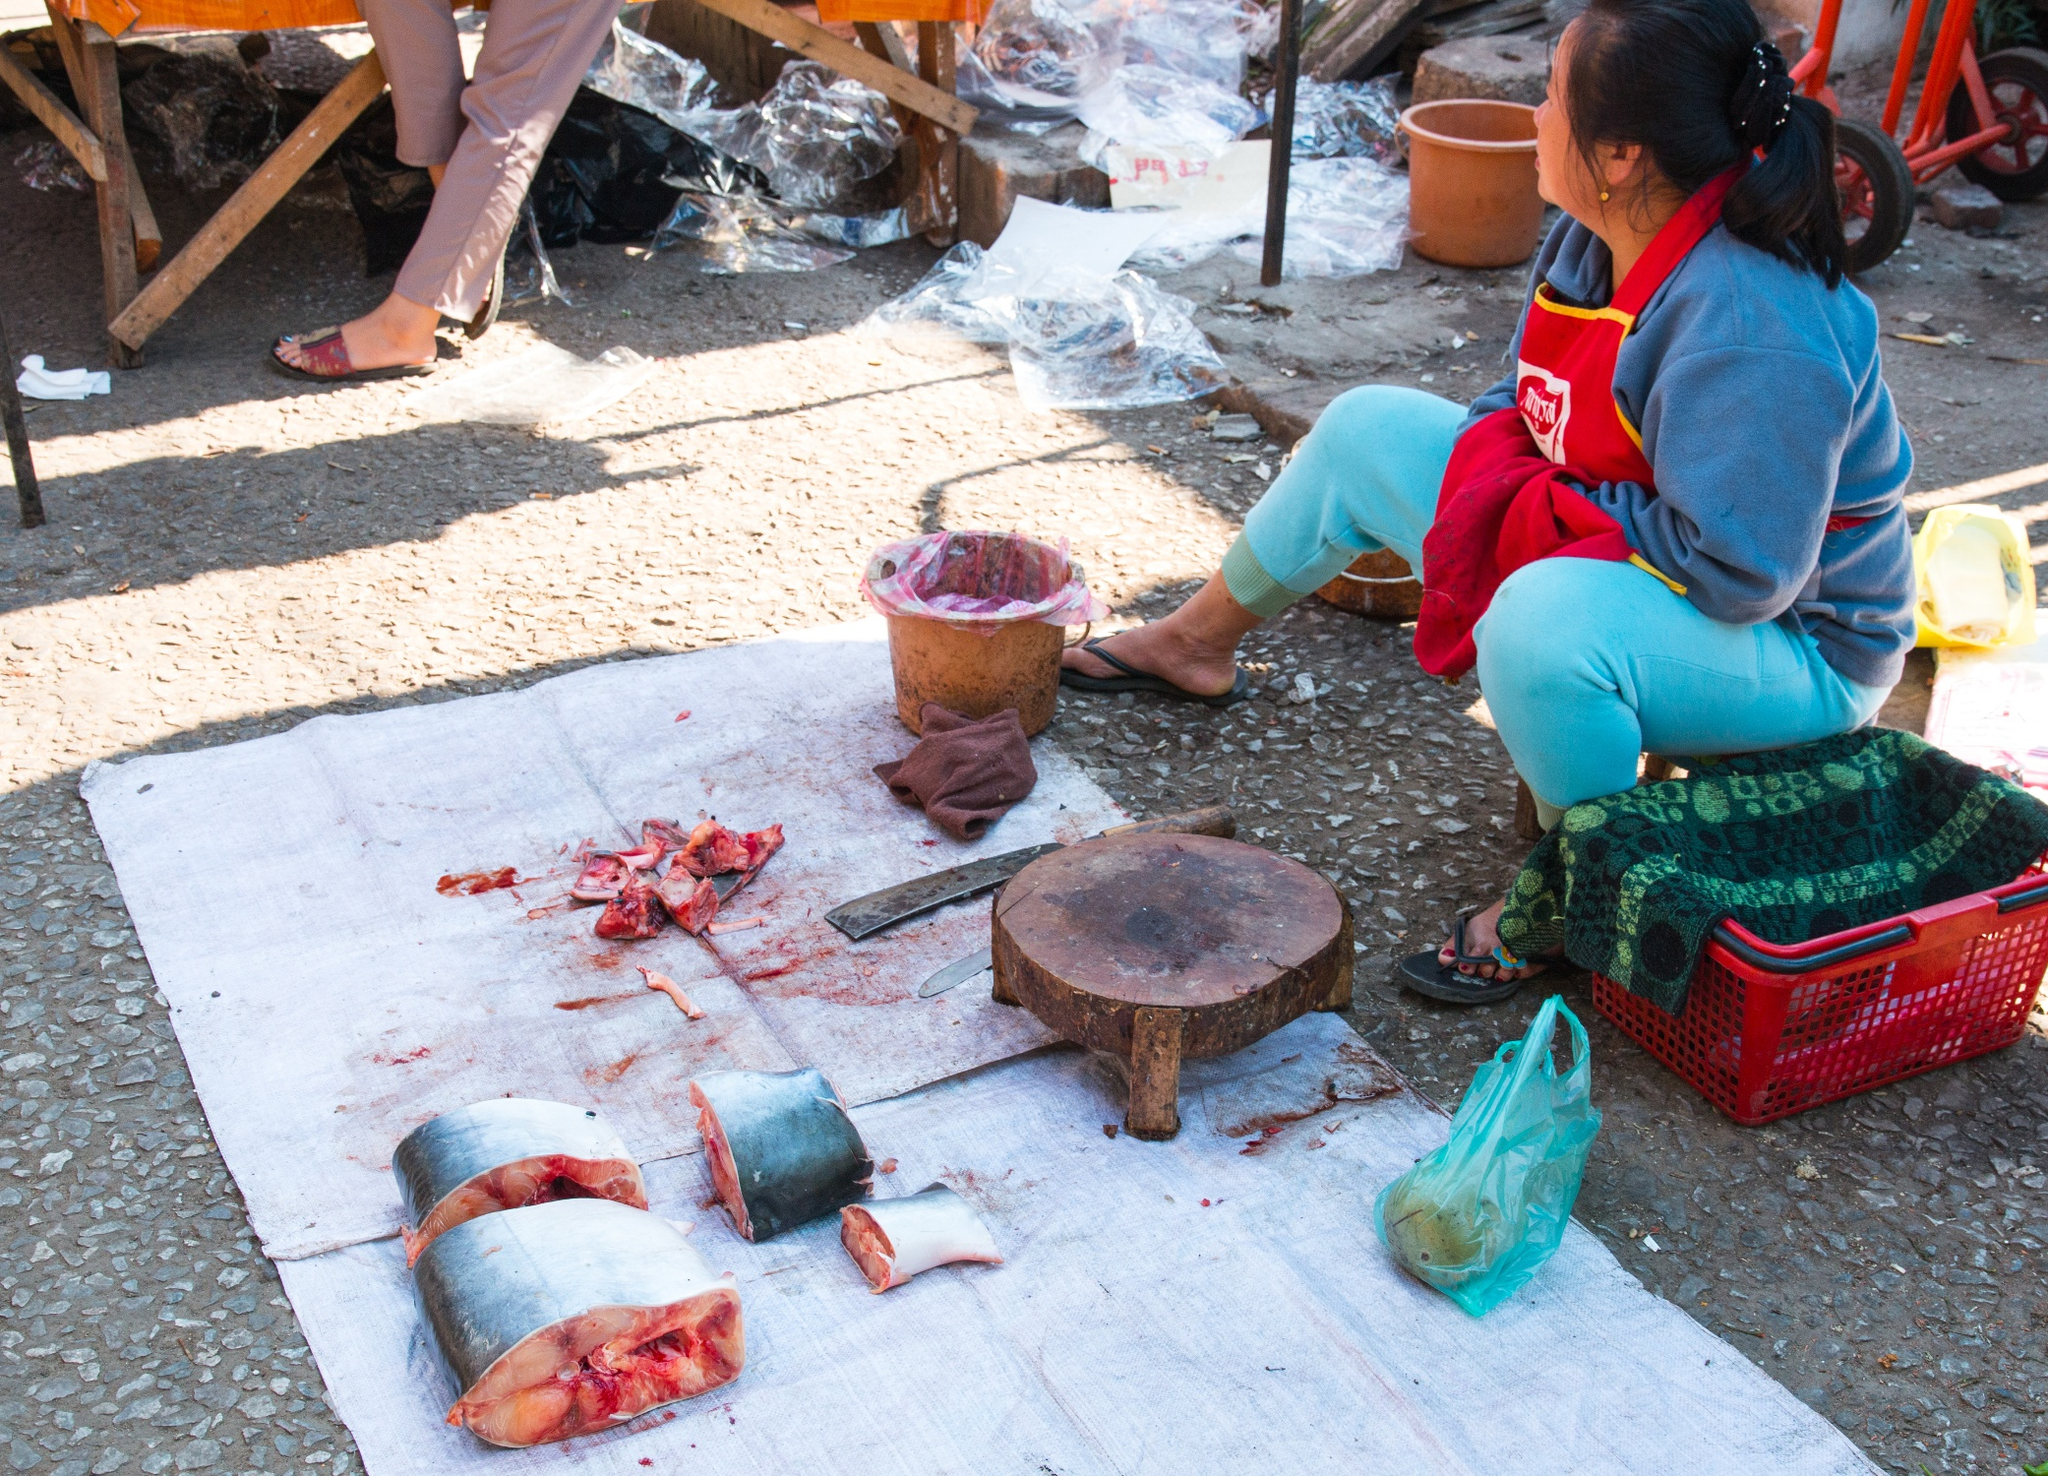If the fish could talk, what story might they tell about their journey to this market? If the fish could speak, they might spin a tale of their swift travel from the depths of the ocean or a nearby river to this vibrant market. They could describe the early morning when fishermen set out into the waters with nets and rods, skillfully capturing their gleaming bodies. The journey would continue with their transportation, often in packed crates, to various vendors who skillfully prepared them like our central figure here. The fish might evoke stories of bustling markets, vivid with colors and sounds, where people haggle and exchange goods, bringing life to the worn textures of the market's wooden stalls and tarpaulin. Compose a poetic interpretation of the scene. In the bustling market, where life and trade intertwine,
A woman sits, her colorful attire a sign.
With a deft hand, she prepares the sea's fine fare,
A tapestry of effort, woven with care.

Tools laid out, gleaming under the sun's warm embrace,
Each slice precise, giving fish its final grace.
Baskets and bags, in colors bright,
Hold secrets of ingredients, tucked out of sight.

The rustic backdrop, a simple wooden frame,
Holds stories of vendors, all sharing the sharegpt4v/same claim.
A market alive, with stories untold,
Where each fish, each person, adds to the manifold.

Here, in the open, beneath the sky's watchful eye,
The woman's work and purpose never wry.
In every cut, in every breath,
Resides a vignette of life's dance with death. 